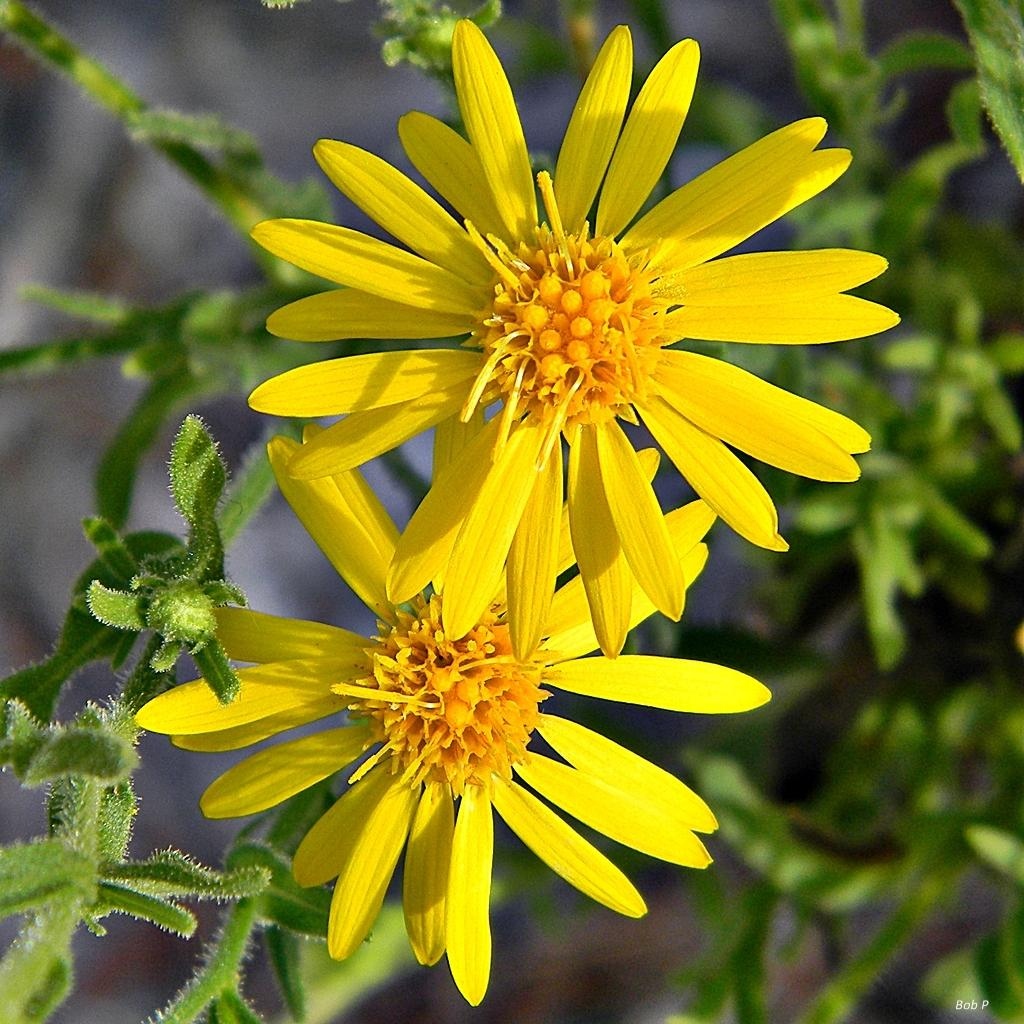What is the main subject of the image? The main subject of the image is plants. How are the plants positioned in the image? There are plants truncated towards the right and left of the image. Are there any additional elements in the image besides the plants? Yes, there are flowers in the image. Can you describe the background of the image? The background of the image is blurred. What type of marble is being used to decorate the grandmother's room in the image? There is no mention of a grandmother or marble in the image; it features plants and flowers. How many bananas are visible in the image? There are no bananas present in the image. 